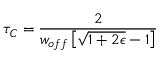Convert formula to latex. <formula><loc_0><loc_0><loc_500><loc_500>\tau _ { C } = { \frac { 2 } { w _ { o f f } \left [ \sqrt { 1 + 2 \epsilon } - 1 \right ] } }</formula> 